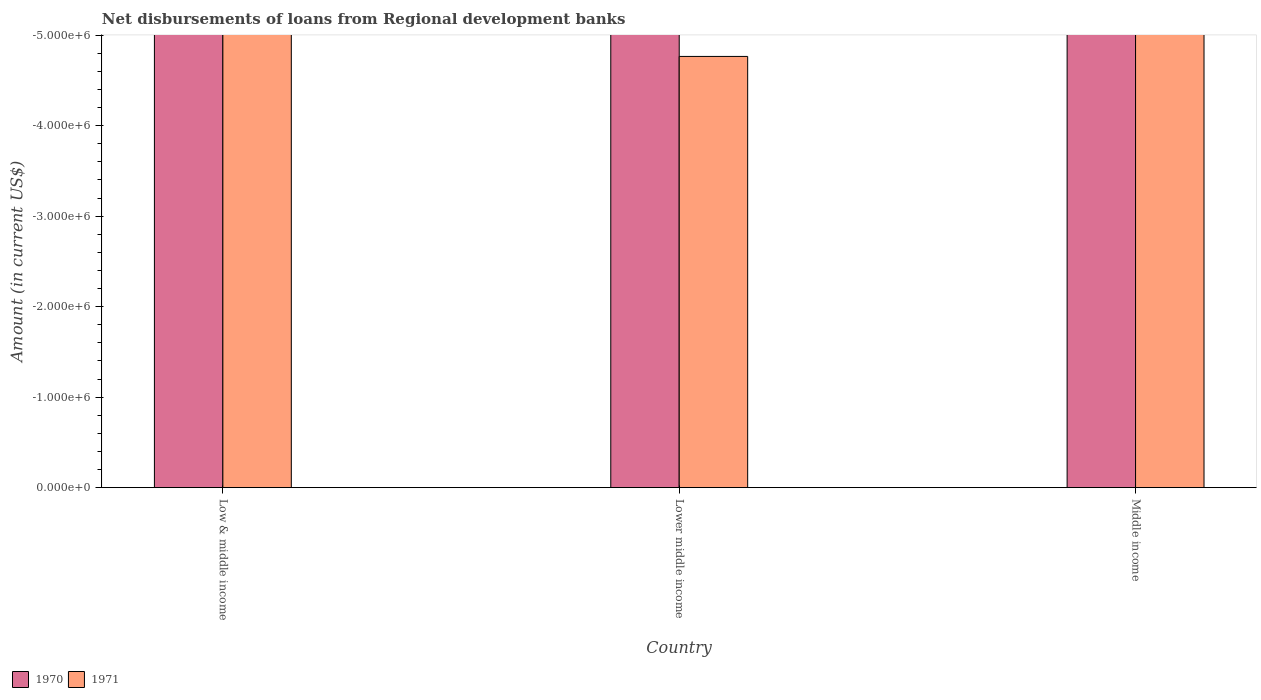How many different coloured bars are there?
Your answer should be compact. 0. In how many cases, is the number of bars for a given country not equal to the number of legend labels?
Offer a very short reply. 3. Across all countries, what is the minimum amount of disbursements of loans from regional development banks in 1971?
Make the answer very short. 0. What is the difference between the amount of disbursements of loans from regional development banks in 1971 in Middle income and the amount of disbursements of loans from regional development banks in 1970 in Low & middle income?
Provide a succinct answer. 0. What is the average amount of disbursements of loans from regional development banks in 1970 per country?
Your response must be concise. 0. In how many countries, is the amount of disbursements of loans from regional development banks in 1971 greater than -4600000 US$?
Offer a very short reply. 0. In how many countries, is the amount of disbursements of loans from regional development banks in 1970 greater than the average amount of disbursements of loans from regional development banks in 1970 taken over all countries?
Your answer should be compact. 0. Are all the bars in the graph horizontal?
Keep it short and to the point. No. Are the values on the major ticks of Y-axis written in scientific E-notation?
Ensure brevity in your answer.  Yes. Does the graph contain any zero values?
Provide a succinct answer. Yes. Does the graph contain grids?
Ensure brevity in your answer.  No. How many legend labels are there?
Offer a terse response. 2. What is the title of the graph?
Make the answer very short. Net disbursements of loans from Regional development banks. What is the label or title of the X-axis?
Your answer should be compact. Country. What is the label or title of the Y-axis?
Make the answer very short. Amount (in current US$). What is the Amount (in current US$) of 1971 in Low & middle income?
Offer a terse response. 0. What is the total Amount (in current US$) of 1970 in the graph?
Make the answer very short. 0. What is the average Amount (in current US$) in 1971 per country?
Your answer should be compact. 0. 